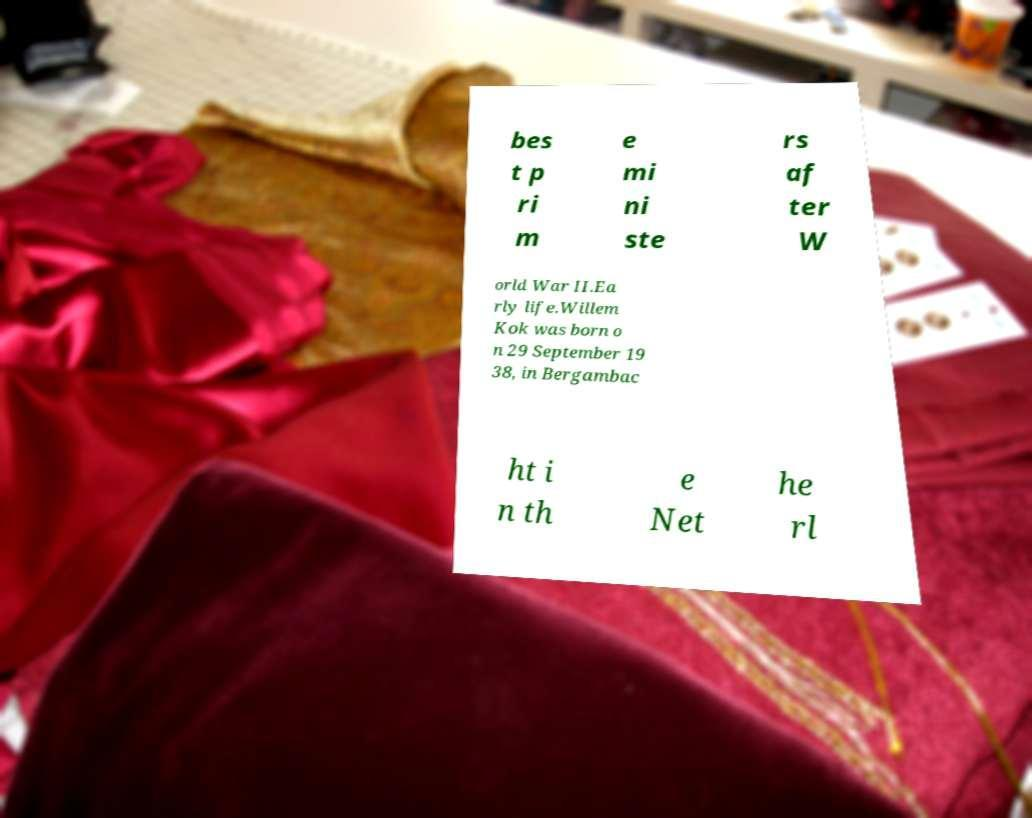Please identify and transcribe the text found in this image. bes t p ri m e mi ni ste rs af ter W orld War II.Ea rly life.Willem Kok was born o n 29 September 19 38, in Bergambac ht i n th e Net he rl 